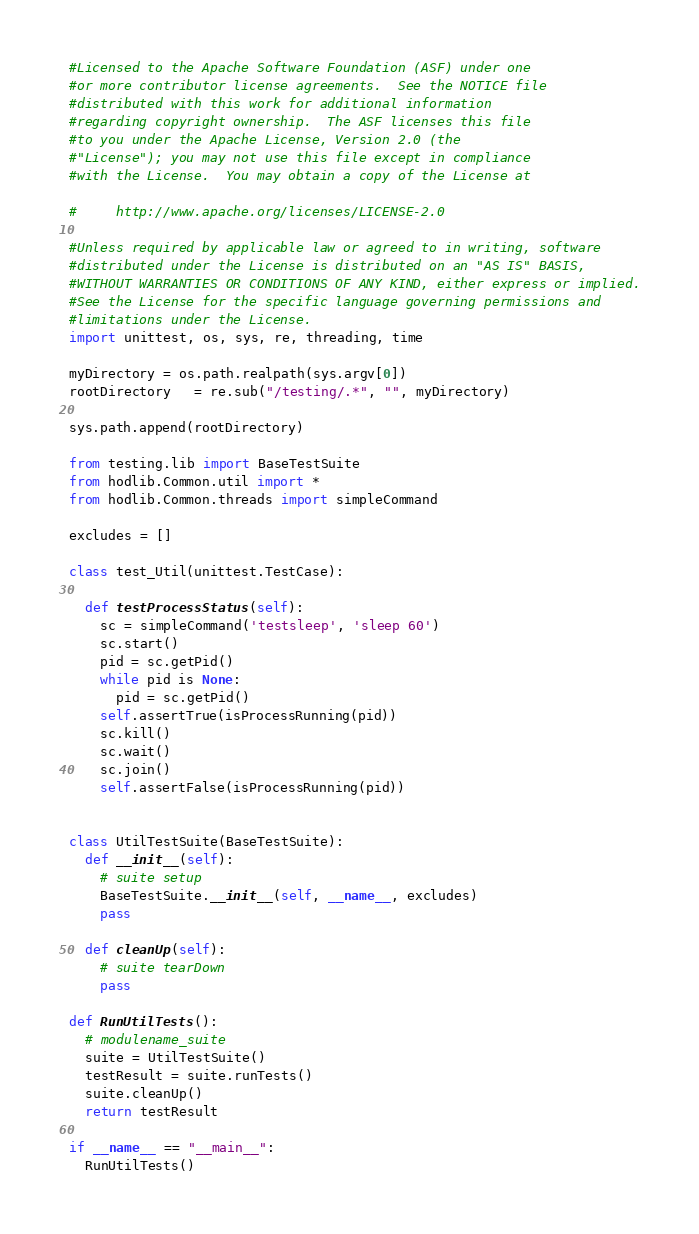Convert code to text. <code><loc_0><loc_0><loc_500><loc_500><_Python_>#Licensed to the Apache Software Foundation (ASF) under one
#or more contributor license agreements.  See the NOTICE file
#distributed with this work for additional information
#regarding copyright ownership.  The ASF licenses this file
#to you under the Apache License, Version 2.0 (the
#"License"); you may not use this file except in compliance
#with the License.  You may obtain a copy of the License at

#     http://www.apache.org/licenses/LICENSE-2.0

#Unless required by applicable law or agreed to in writing, software
#distributed under the License is distributed on an "AS IS" BASIS,
#WITHOUT WARRANTIES OR CONDITIONS OF ANY KIND, either express or implied.
#See the License for the specific language governing permissions and
#limitations under the License.
import unittest, os, sys, re, threading, time

myDirectory = os.path.realpath(sys.argv[0])
rootDirectory   = re.sub("/testing/.*", "", myDirectory)

sys.path.append(rootDirectory)

from testing.lib import BaseTestSuite
from hodlib.Common.util import *
from hodlib.Common.threads import simpleCommand

excludes = []

class test_Util(unittest.TestCase):

  def testProcessStatus(self):
    sc = simpleCommand('testsleep', 'sleep 60')
    sc.start()
    pid = sc.getPid()
    while pid is None:
      pid = sc.getPid()
    self.assertTrue(isProcessRunning(pid))
    sc.kill()
    sc.wait()
    sc.join()
    self.assertFalse(isProcessRunning(pid))
    

class UtilTestSuite(BaseTestSuite):
  def __init__(self):
    # suite setup
    BaseTestSuite.__init__(self, __name__, excludes)
    pass
  
  def cleanUp(self):
    # suite tearDown
    pass

def RunUtilTests():
  # modulename_suite
  suite = UtilTestSuite()
  testResult = suite.runTests()
  suite.cleanUp()
  return testResult

if __name__ == "__main__":
  RunUtilTests()
</code> 